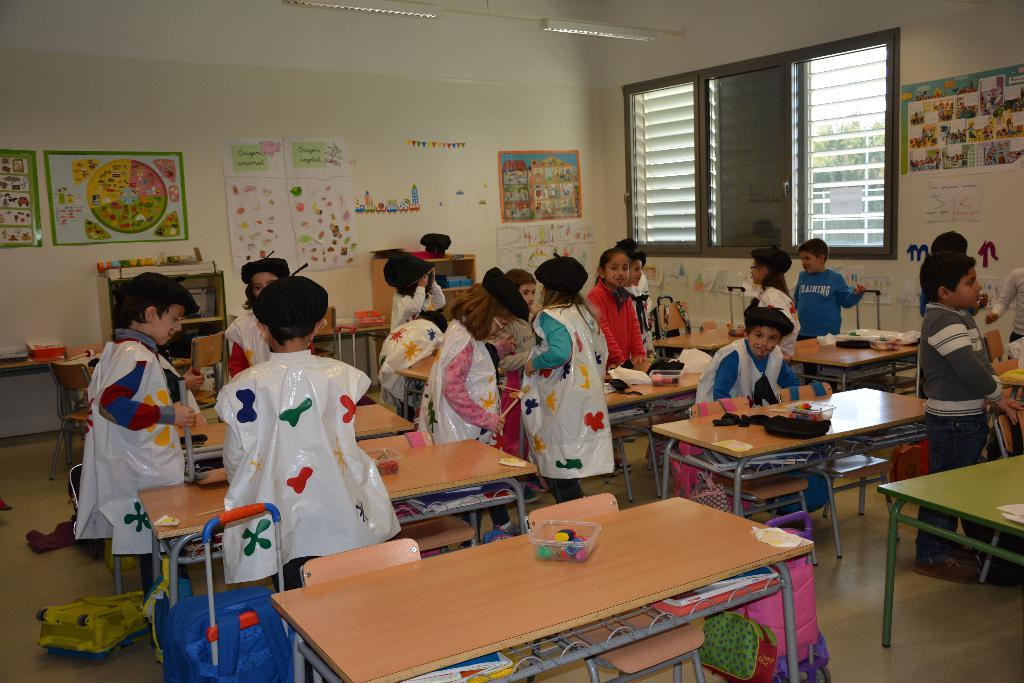What is happening in the image? There are children standing in the class. What can be seen in the background of the image? There is a wall, posts attached to the wall, a window, and a window blind in the background. What type of faucet is present in the image? There is no faucet present in the image. How many rods can be seen in the image? There are no rods visible in the image. 